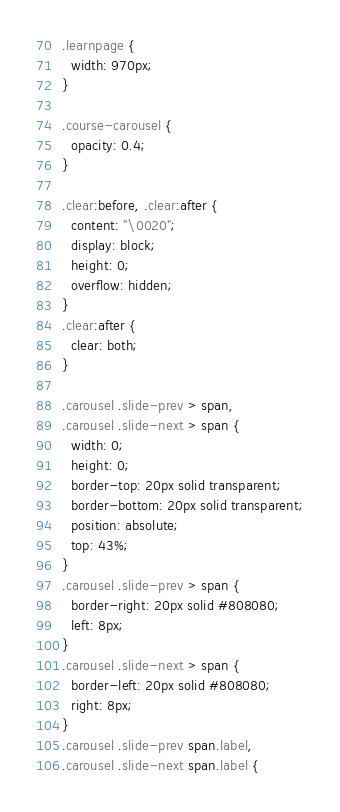Convert code to text. <code><loc_0><loc_0><loc_500><loc_500><_CSS_>.learnpage {
  width: 970px;
}

.course-carousel {
  opacity: 0.4;
}

.clear:before, .clear:after {
  content: "\0020";
  display: block;
  height: 0;
  overflow: hidden;
}
.clear:after {
  clear: both;
}

.carousel .slide-prev > span,
.carousel .slide-next > span {
  width: 0;
  height: 0;
  border-top: 20px solid transparent;
  border-bottom: 20px solid transparent;
  position: absolute;
  top: 43%;
}
.carousel .slide-prev > span {
  border-right: 20px solid #808080;
  left: 8px;
}
.carousel .slide-next > span {
  border-left: 20px solid #808080;
  right: 8px;
}
.carousel .slide-prev span.label,
.carousel .slide-next span.label {</code> 